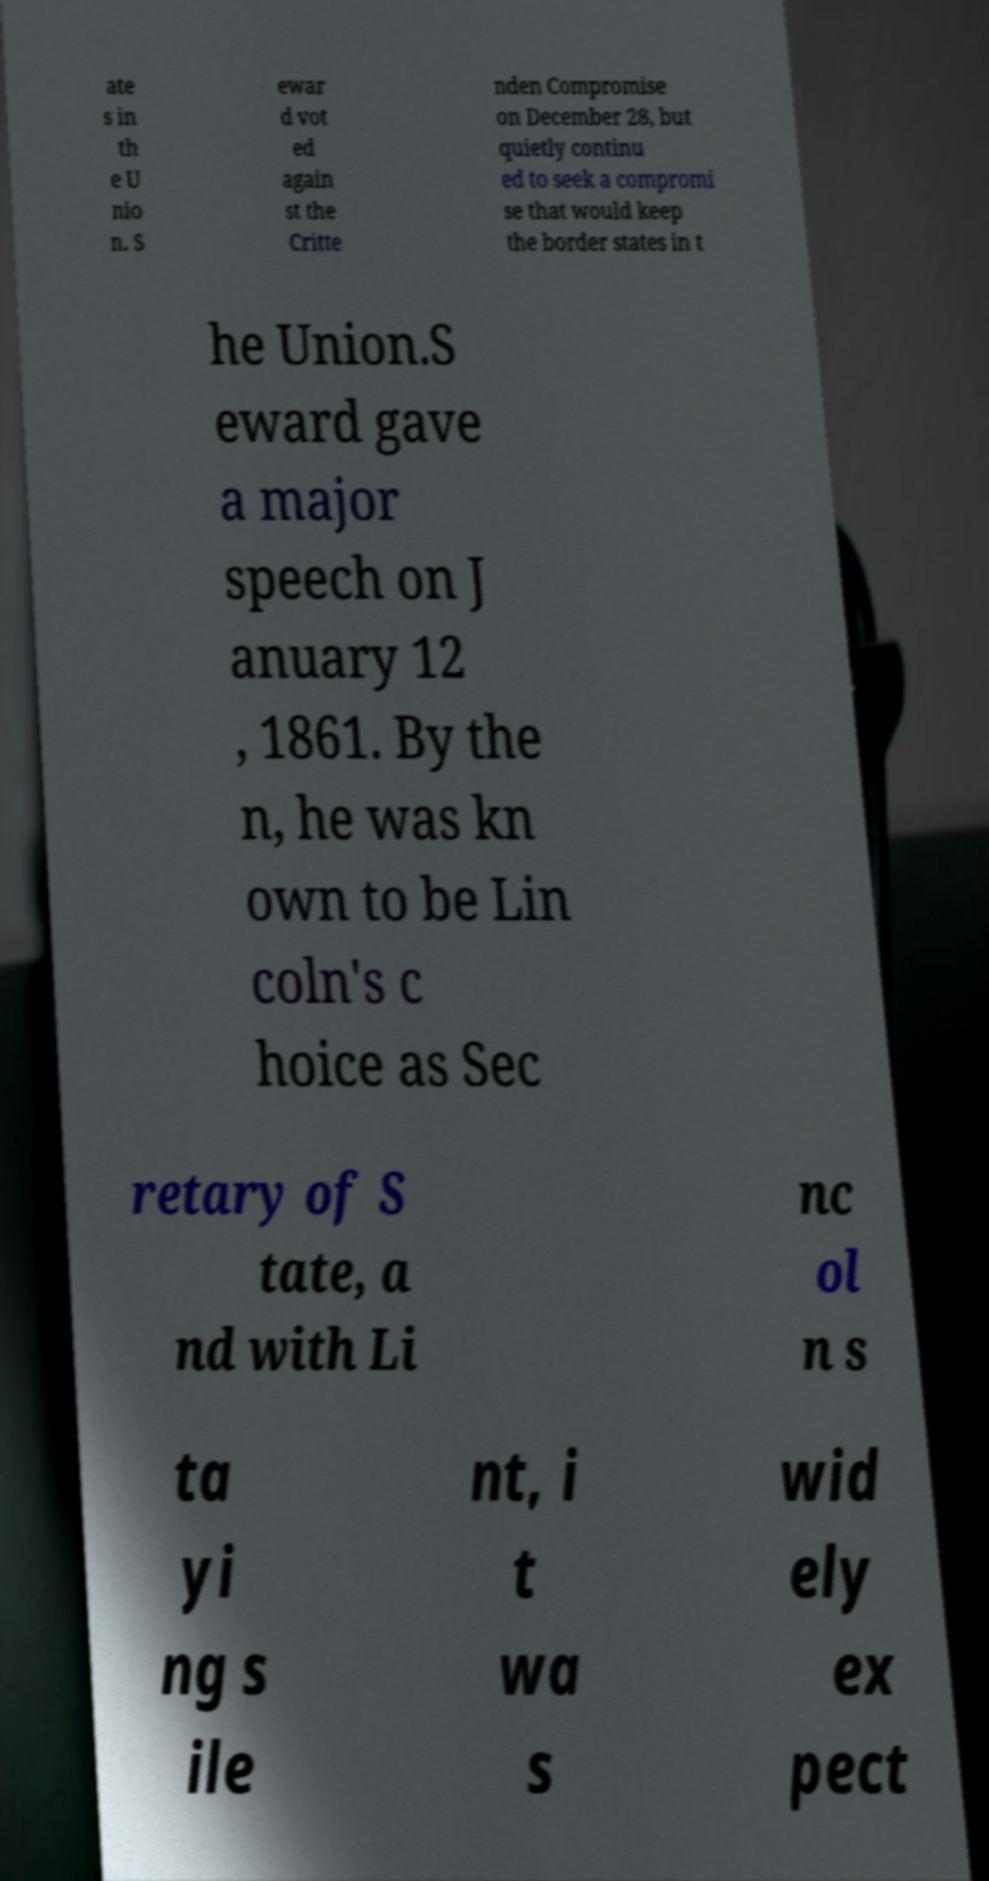There's text embedded in this image that I need extracted. Can you transcribe it verbatim? ate s in th e U nio n. S ewar d vot ed again st the Critte nden Compromise on December 28, but quietly continu ed to seek a compromi se that would keep the border states in t he Union.S eward gave a major speech on J anuary 12 , 1861. By the n, he was kn own to be Lin coln's c hoice as Sec retary of S tate, a nd with Li nc ol n s ta yi ng s ile nt, i t wa s wid ely ex pect 